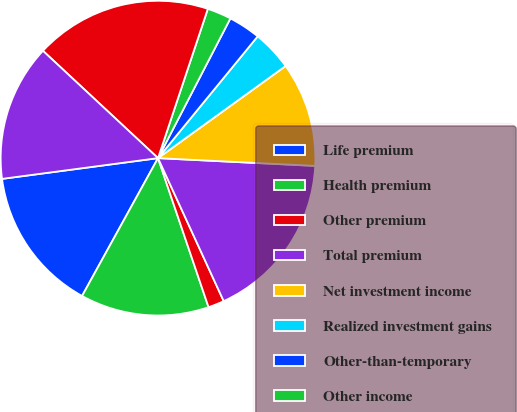<chart> <loc_0><loc_0><loc_500><loc_500><pie_chart><fcel>Life premium<fcel>Health premium<fcel>Other premium<fcel>Total premium<fcel>Net investment income<fcel>Realized investment gains<fcel>Other-than-temporary<fcel>Other income<fcel>Total revenue<fcel>Life policyholder benefits<nl><fcel>14.88%<fcel>13.22%<fcel>1.65%<fcel>17.36%<fcel>10.74%<fcel>4.13%<fcel>3.31%<fcel>2.48%<fcel>18.18%<fcel>14.05%<nl></chart> 